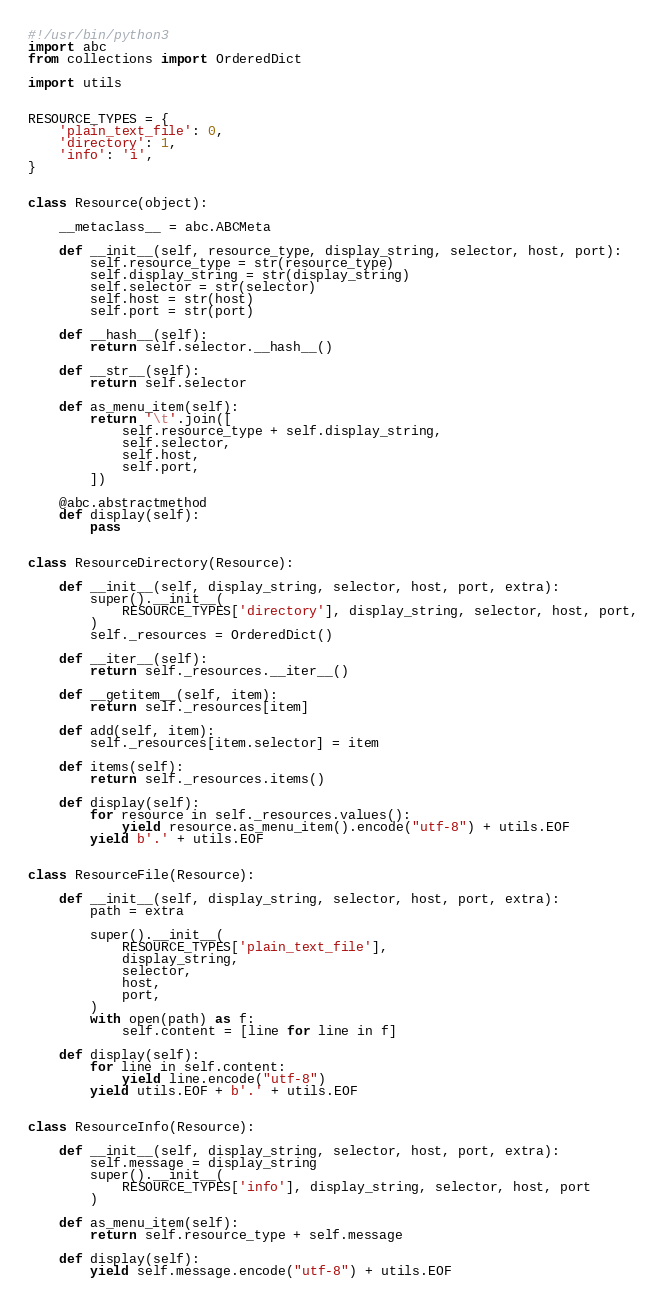<code> <loc_0><loc_0><loc_500><loc_500><_Python_>#!/usr/bin/python3
import abc
from collections import OrderedDict

import utils


RESOURCE_TYPES = {
    'plain_text_file': 0,
    'directory': 1,
    'info': 'i',
}


class Resource(object):

    __metaclass__ = abc.ABCMeta

    def __init__(self, resource_type, display_string, selector, host, port):
        self.resource_type = str(resource_type)
        self.display_string = str(display_string)
        self.selector = str(selector)
        self.host = str(host)
        self.port = str(port)

    def __hash__(self):
        return self.selector.__hash__()

    def __str__(self):
        return self.selector

    def as_menu_item(self):
        return '\t'.join([
            self.resource_type + self.display_string,
            self.selector,
            self.host,
            self.port,
        ])

    @abc.abstractmethod
    def display(self):
        pass


class ResourceDirectory(Resource):

    def __init__(self, display_string, selector, host, port, extra):
        super().__init__(
            RESOURCE_TYPES['directory'], display_string, selector, host, port,
        )
        self._resources = OrderedDict()

    def __iter__(self):
        return self._resources.__iter__()

    def __getitem__(self, item):
        return self._resources[item]

    def add(self, item):
        self._resources[item.selector] = item

    def items(self):
        return self._resources.items()

    def display(self):
        for resource in self._resources.values():
            yield resource.as_menu_item().encode("utf-8") + utils.EOF
        yield b'.' + utils.EOF


class ResourceFile(Resource):

    def __init__(self, display_string, selector, host, port, extra):
        path = extra

        super().__init__(
            RESOURCE_TYPES['plain_text_file'],
            display_string,
            selector,
            host,
            port,
        )
        with open(path) as f:
            self.content = [line for line in f]

    def display(self):
        for line in self.content:
            yield line.encode("utf-8")
        yield utils.EOF + b'.' + utils.EOF


class ResourceInfo(Resource):

    def __init__(self, display_string, selector, host, port, extra):
        self.message = display_string
        super().__init__(
            RESOURCE_TYPES['info'], display_string, selector, host, port
        )

    def as_menu_item(self):
        return self.resource_type + self.message

    def display(self):
        yield self.message.encode("utf-8") + utils.EOF
</code> 